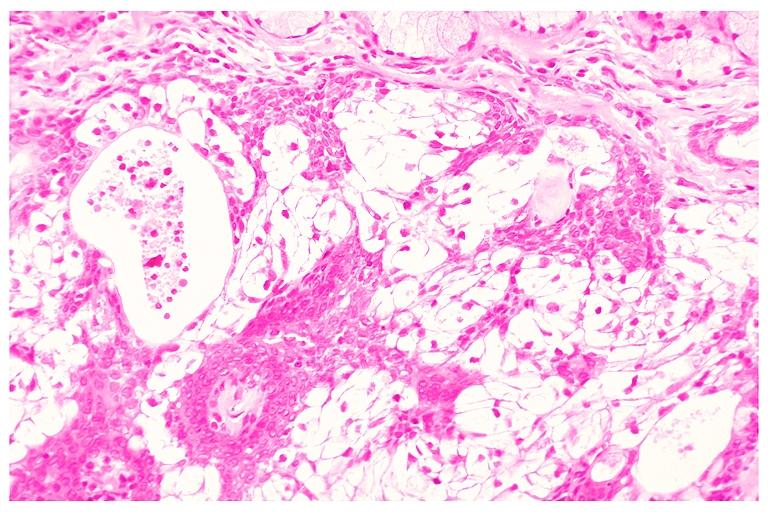does this image show mucoepidermoid carcinoma?
Answer the question using a single word or phrase. Yes 